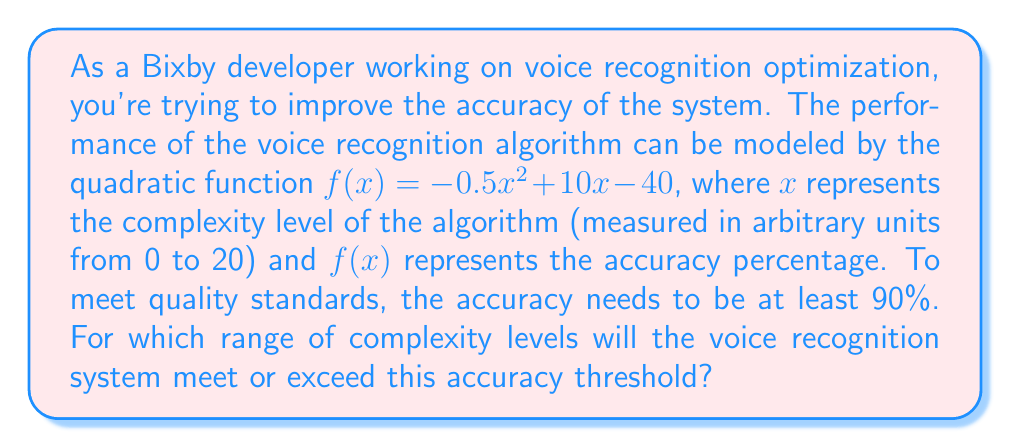Provide a solution to this math problem. To solve this problem, we need to set up and solve a quadratic inequality:

1) The inequality we need to solve is:
   $$f(x) \geq 90$$
   $$-0.5x^2 + 10x - 40 \geq 90$$

2) Rearrange the inequality:
   $$-0.5x^2 + 10x - 130 \geq 0$$

3) Multiply everything by -2 to make the coefficient of $x^2$ positive. Remember to flip the inequality sign:
   $$x^2 - 20x + 260 \leq 0$$

4) This is a quadratic inequality. To solve it, we first need to find the roots of the quadratic equation:
   $$x^2 - 20x + 260 = 0$$

5) Use the quadratic formula: $x = \frac{-b \pm \sqrt{b^2 - 4ac}}{2a}$
   Here, $a=1$, $b=-20$, and $c=260$

6) Solving:
   $$x = \frac{20 \pm \sqrt{400 - 1040}}{2} = \frac{20 \pm \sqrt{-640}}{2}$$

   $$x = \frac{20 \pm 8\sqrt{10}}{2} = 10 \pm 4\sqrt{10}$$

7) So the roots are:
   $$x_1 = 10 - 4\sqrt{10} \approx 7.35$$
   $$x_2 = 10 + 4\sqrt{10} \approx 12.65$$

8) For a quadratic inequality of the form $ax^2 + bx + c \leq 0$ where $a > 0$, the solution is the interval between the roots.

Therefore, the voice recognition system will meet or exceed 90% accuracy when the complexity level is between approximately 7.35 and 12.65.
Answer: The voice recognition system will meet or exceed 90% accuracy when the complexity level $x$ is in the range:
$$10 - 4\sqrt{10} \leq x \leq 10 + 4\sqrt{10}$$
or approximately:
$$7.35 \leq x \leq 12.65$$ 